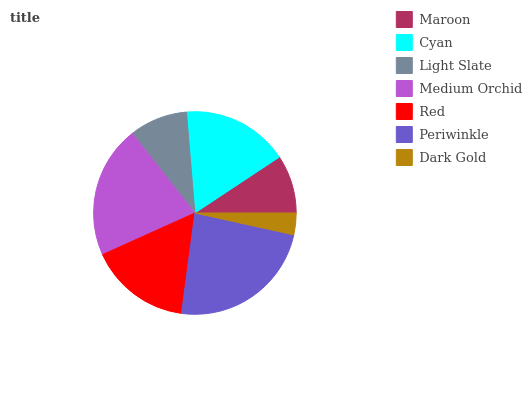Is Dark Gold the minimum?
Answer yes or no. Yes. Is Periwinkle the maximum?
Answer yes or no. Yes. Is Cyan the minimum?
Answer yes or no. No. Is Cyan the maximum?
Answer yes or no. No. Is Cyan greater than Maroon?
Answer yes or no. Yes. Is Maroon less than Cyan?
Answer yes or no. Yes. Is Maroon greater than Cyan?
Answer yes or no. No. Is Cyan less than Maroon?
Answer yes or no. No. Is Red the high median?
Answer yes or no. Yes. Is Red the low median?
Answer yes or no. Yes. Is Light Slate the high median?
Answer yes or no. No. Is Maroon the low median?
Answer yes or no. No. 